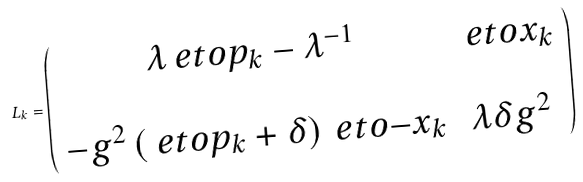<formula> <loc_0><loc_0><loc_500><loc_500>L _ { k } = \left ( \begin{array} { c c } \lambda \ e t o { p _ { k } } - \lambda ^ { - 1 } & \ e t o { x _ { k } } \\ \\ - g ^ { 2 } \left ( \ e t o { p _ { k } } + \delta \right ) \ e t o { - x _ { k } } & \lambda \delta g ^ { 2 } \end{array} \right )</formula> 